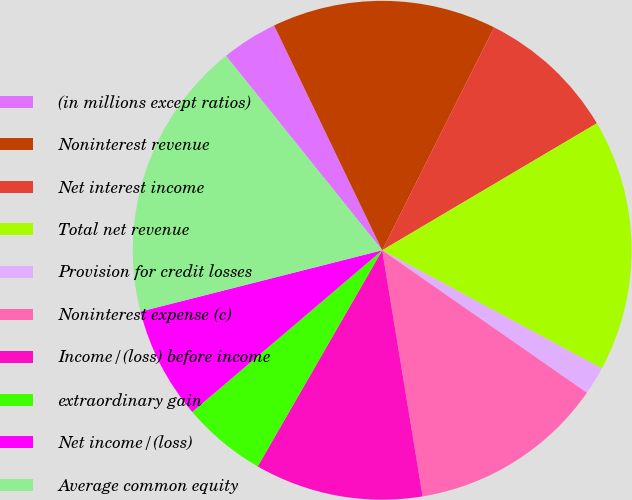Convert chart. <chart><loc_0><loc_0><loc_500><loc_500><pie_chart><fcel>(in millions except ratios)<fcel>Noninterest revenue<fcel>Net interest income<fcel>Total net revenue<fcel>Provision for credit losses<fcel>Noninterest expense (c)<fcel>Income/(loss) before income<fcel>extraordinary gain<fcel>Net income/(loss)<fcel>Average common equity<nl><fcel>3.64%<fcel>14.54%<fcel>9.09%<fcel>16.36%<fcel>1.82%<fcel>12.73%<fcel>10.91%<fcel>5.46%<fcel>7.27%<fcel>18.18%<nl></chart> 